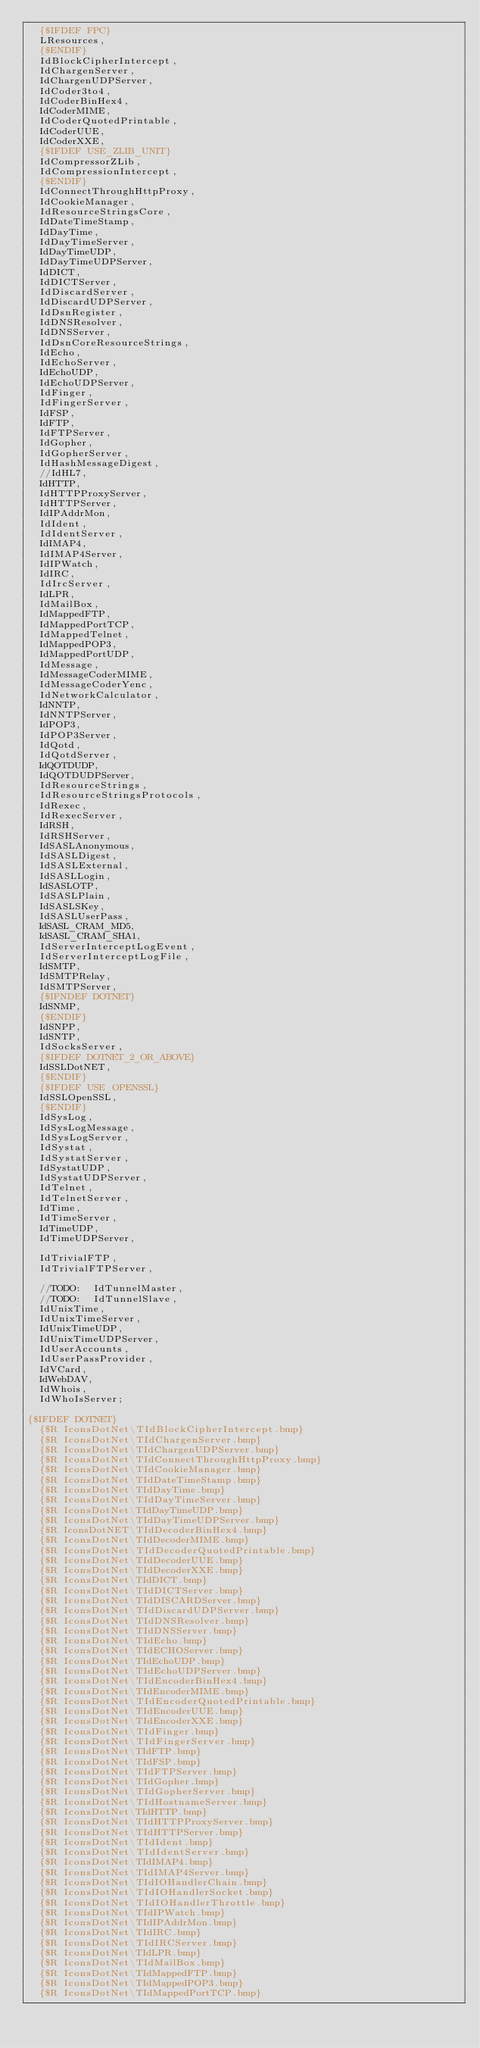<code> <loc_0><loc_0><loc_500><loc_500><_Pascal_>  {$IFDEF FPC}
  LResources,
  {$ENDIF}
  IdBlockCipherIntercept,
  IdChargenServer,
  IdChargenUDPServer,
  IdCoder3to4,
  IdCoderBinHex4,
  IdCoderMIME,
  IdCoderQuotedPrintable,
  IdCoderUUE,
  IdCoderXXE,
  {$IFDEF USE_ZLIB_UNIT}
  IdCompressorZLib,
  IdCompressionIntercept,
  {$ENDIF}
  IdConnectThroughHttpProxy,
  IdCookieManager,
  IdResourceStringsCore,
  IdDateTimeStamp,
  IdDayTime,
  IdDayTimeServer,
  IdDayTimeUDP,
  IdDayTimeUDPServer,
  IdDICT,
  IdDICTServer,
  IdDiscardServer,
  IdDiscardUDPServer,
  IdDsnRegister,
  IdDNSResolver,
  IdDNSServer,
  IdDsnCoreResourceStrings,
  IdEcho,
  IdEchoServer,
  IdEchoUDP,
  IdEchoUDPServer,
  IdFinger,
  IdFingerServer,
  IdFSP,
  IdFTP,
  IdFTPServer,
  IdGopher,
  IdGopherServer,
  IdHashMessageDigest,
  //IdHL7,
  IdHTTP,
  IdHTTPProxyServer,
  IdHTTPServer,
  IdIPAddrMon,
  IdIdent,
  IdIdentServer,
  IdIMAP4,
  IdIMAP4Server,
  IdIPWatch,
  IdIRC,
  IdIrcServer,
  IdLPR,
  IdMailBox,
  IdMappedFTP,
  IdMappedPortTCP,
  IdMappedTelnet,
  IdMappedPOP3,
  IdMappedPortUDP,
  IdMessage,
  IdMessageCoderMIME,
  IdMessageCoderYenc,
  IdNetworkCalculator,
  IdNNTP,
  IdNNTPServer,
  IdPOP3,
  IdPOP3Server,
  IdQotd,
  IdQotdServer,
  IdQOTDUDP,
  IdQOTDUDPServer,
  IdResourceStrings,
  IdResourceStringsProtocols,
  IdRexec,
  IdRexecServer,
  IdRSH,
  IdRSHServer,
  IdSASLAnonymous,
  IdSASLDigest,
  IdSASLExternal,
  IdSASLLogin,
  IdSASLOTP,
  IdSASLPlain,
  IdSASLSKey,
  IdSASLUserPass,
  IdSASL_CRAM_MD5,
  IdSASL_CRAM_SHA1,
  IdServerInterceptLogEvent,
  IdServerInterceptLogFile,
  IdSMTP,
  IdSMTPRelay,
  IdSMTPServer,
  {$IFNDEF DOTNET}
  IdSNMP,
  {$ENDIF}
  IdSNPP,
  IdSNTP,
  IdSocksServer,
  {$IFDEF DOTNET_2_OR_ABOVE}
  IdSSLDotNET,
  {$ENDIF}
  {$IFDEF USE_OPENSSL}
  IdSSLOpenSSL,
  {$ENDIF}
  IdSysLog,
  IdSysLogMessage,
  IdSysLogServer,
  IdSystat,
  IdSystatServer,
  IdSystatUDP,
  IdSystatUDPServer,
  IdTelnet,
  IdTelnetServer,
  IdTime,
  IdTimeServer,
  IdTimeUDP,
  IdTimeUDPServer,

  IdTrivialFTP,
  IdTrivialFTPServer,

  //TODO:  IdTunnelMaster,
  //TODO:  IdTunnelSlave,
  IdUnixTime,
  IdUnixTimeServer,
  IdUnixTimeUDP,
  IdUnixTimeUDPServer,
  IdUserAccounts,
  IdUserPassProvider,
  IdVCard,
  IdWebDAV,
  IdWhois,
  IdWhoIsServer;

{$IFDEF DOTNET}
  {$R IconsDotNet\TIdBlockCipherIntercept.bmp}
  {$R IconsDotNet\TIdChargenServer.bmp}
  {$R IconsDotNet\TIdChargenUDPServer.bmp}
  {$R IconsDotNet\TIdConnectThroughHttpProxy.bmp}
  {$R IconsDotNet\TIdCookieManager.bmp}
  {$R IconsDotNet\TIdDateTimeStamp.bmp}
  {$R IconsDotNet\TIdDayTime.bmp}
  {$R IconsDotNet\TIdDayTimeServer.bmp}
  {$R IconsDotNet\TIdDayTimeUDP.bmp}
  {$R IconsDotNet\TIdDayTimeUDPServer.bmp}
  {$R IconsDotNET\TIdDecoderBinHex4.bmp}  
  {$R IconsDotNet\TIdDecoderMIME.bmp}
  {$R IconsDotNet\TIdDecoderQuotedPrintable.bmp}
  {$R IconsDotNet\TIdDecoderUUE.bmp}
  {$R IconsDotNet\TIdDecoderXXE.bmp}
  {$R IconsDotNet\TIdDICT.bmp}
  {$R IconsDotNet\TIdDICTServer.bmp}
  {$R IconsDotNet\TIdDISCARDServer.bmp}
  {$R IconsDotNet\TIdDiscardUDPServer.bmp}
  {$R IconsDotNet\TIdDNSResolver.bmp}
  {$R IconsDotNet\TIdDNSServer.bmp}
  {$R IconsDotNet\TIdEcho.bmp}
  {$R IconsDotNet\TIdECHOServer.bmp}
  {$R IconsDotNet\TIdEchoUDP.bmp}
  {$R IconsDotNet\TIdEchoUDPServer.bmp}
  {$R IconsDotNet\TIdEncoderBinHex4.bmp}
  {$R IconsDotNet\TIdEncoderMIME.bmp}
  {$R IconsDotNet\TIdEncoderQuotedPrintable.bmp}
  {$R IconsDotNet\TIdEncoderUUE.bmp}
  {$R IconsDotNet\TIdEncoderXXE.bmp}
  {$R IconsDotNet\TIdFinger.bmp}
  {$R IconsDotNet\TIdFingerServer.bmp}
  {$R IconsDotNet\TIdFTP.bmp}
  {$R IconsDotNet\TIdFSP.bmp}
  {$R IconsDotNet\TIdFTPServer.bmp}
  {$R IconsDotNet\TIdGopher.bmp}
  {$R IconsDotNet\TIdGopherServer.bmp}
  {$R IconsDotNet\TIdHostnameServer.bmp}
  {$R IconsDotNet\TIdHTTP.bmp}
  {$R IconsDotNet\TIdHTTPProxyServer.bmp}
  {$R IconsDotNet\TIdHTTPServer.bmp}
  {$R IconsDotNet\TIdIdent.bmp}
  {$R IconsDotNet\TIdIdentServer.bmp}
  {$R IconsDotNet\TIdIMAP4.bmp}
  {$R IconsDotNet\TIdIMAP4Server.bmp}
  {$R IconsDotNet\TIdIOHandlerChain.bmp}
  {$R IconsDotNet\TIdIOHandlerSocket.bmp}
  {$R IconsDotNet\TIdIOHandlerThrottle.bmp}
  {$R IconsDotNet\TIdIPWatch.bmp}
  {$R IconsDotNet\TIdIPAddrMon.bmp}
  {$R IconsDotNet\TIdIRC.bmp}
  {$R IconsDotNet\TIdIRCServer.bmp}
  {$R IconsDotNet\TIdLPR.bmp}
  {$R IconsDotNet\TIdMailBox.bmp}
  {$R IconsDotNet\TIdMappedFTP.bmp}
  {$R IconsDotNet\TIdMappedPOP3.bmp}
  {$R IconsDotNet\TIdMappedPortTCP.bmp}</code> 